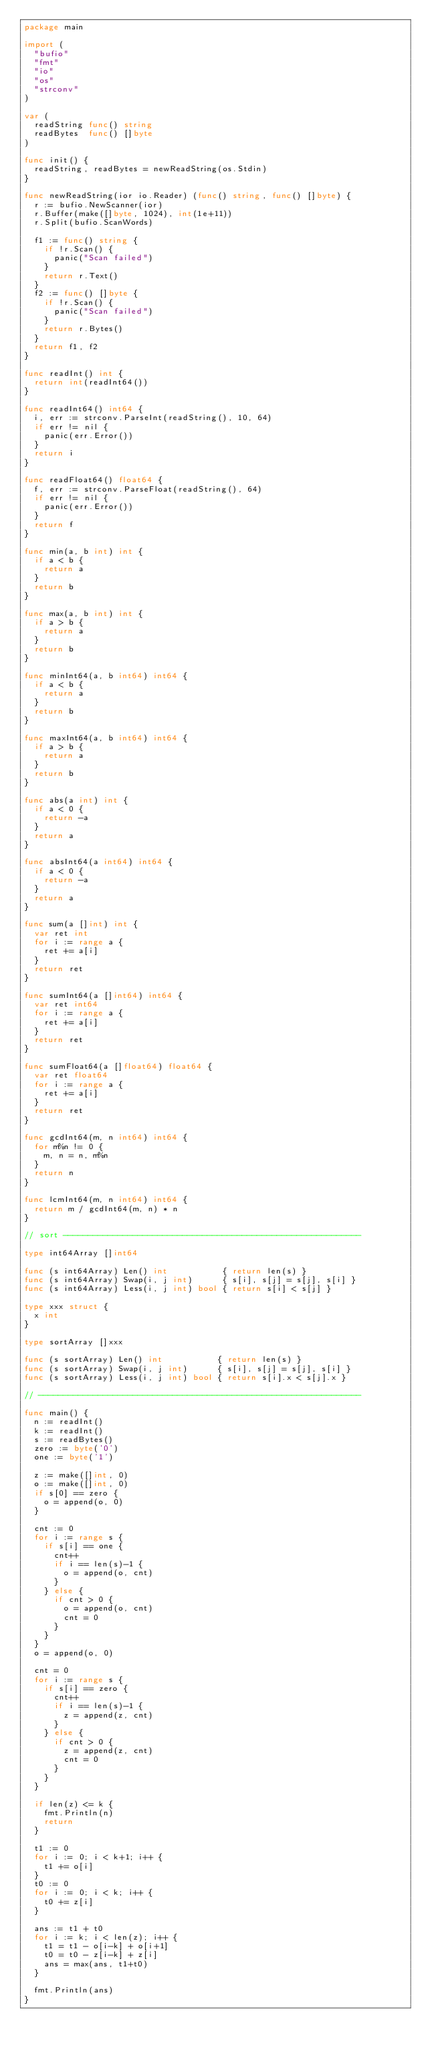Convert code to text. <code><loc_0><loc_0><loc_500><loc_500><_Go_>package main

import (
	"bufio"
	"fmt"
	"io"
	"os"
	"strconv"
)

var (
	readString func() string
	readBytes  func() []byte
)

func init() {
	readString, readBytes = newReadString(os.Stdin)
}

func newReadString(ior io.Reader) (func() string, func() []byte) {
	r := bufio.NewScanner(ior)
	r.Buffer(make([]byte, 1024), int(1e+11))
	r.Split(bufio.ScanWords)

	f1 := func() string {
		if !r.Scan() {
			panic("Scan failed")
		}
		return r.Text()
	}
	f2 := func() []byte {
		if !r.Scan() {
			panic("Scan failed")
		}
		return r.Bytes()
	}
	return f1, f2
}

func readInt() int {
	return int(readInt64())
}

func readInt64() int64 {
	i, err := strconv.ParseInt(readString(), 10, 64)
	if err != nil {
		panic(err.Error())
	}
	return i
}

func readFloat64() float64 {
	f, err := strconv.ParseFloat(readString(), 64)
	if err != nil {
		panic(err.Error())
	}
	return f
}

func min(a, b int) int {
	if a < b {
		return a
	}
	return b
}

func max(a, b int) int {
	if a > b {
		return a
	}
	return b
}

func minInt64(a, b int64) int64 {
	if a < b {
		return a
	}
	return b
}

func maxInt64(a, b int64) int64 {
	if a > b {
		return a
	}
	return b
}

func abs(a int) int {
	if a < 0 {
		return -a
	}
	return a
}

func absInt64(a int64) int64 {
	if a < 0 {
		return -a
	}
	return a
}

func sum(a []int) int {
	var ret int
	for i := range a {
		ret += a[i]
	}
	return ret
}

func sumInt64(a []int64) int64 {
	var ret int64
	for i := range a {
		ret += a[i]
	}
	return ret
}

func sumFloat64(a []float64) float64 {
	var ret float64
	for i := range a {
		ret += a[i]
	}
	return ret
}

func gcdInt64(m, n int64) int64 {
	for m%n != 0 {
		m, n = n, m%n
	}
	return n
}

func lcmInt64(m, n int64) int64 {
	return m / gcdInt64(m, n) * n
}

// sort ------------------------------------------------------------

type int64Array []int64

func (s int64Array) Len() int           { return len(s) }
func (s int64Array) Swap(i, j int)      { s[i], s[j] = s[j], s[i] }
func (s int64Array) Less(i, j int) bool { return s[i] < s[j] }

type xxx struct {
	x int
}

type sortArray []xxx

func (s sortArray) Len() int           { return len(s) }
func (s sortArray) Swap(i, j int)      { s[i], s[j] = s[j], s[i] }
func (s sortArray) Less(i, j int) bool { return s[i].x < s[j].x }

// -----------------------------------------------------------------

func main() {
	n := readInt()
	k := readInt()
	s := readBytes()
	zero := byte('0')
	one := byte('1')

	z := make([]int, 0)
	o := make([]int, 0)
	if s[0] == zero {
		o = append(o, 0)
	}

	cnt := 0
	for i := range s {
		if s[i] == one {
			cnt++
			if i == len(s)-1 {
				o = append(o, cnt)
			}
		} else {
			if cnt > 0 {
				o = append(o, cnt)
				cnt = 0
			}
		}
	}
	o = append(o, 0)

	cnt = 0
	for i := range s {
		if s[i] == zero {
			cnt++
			if i == len(s)-1 {
				z = append(z, cnt)
			}
		} else {
			if cnt > 0 {
				z = append(z, cnt)
				cnt = 0
			}
		}
	}

	if len(z) <= k {
		fmt.Println(n)
		return
	}

	t1 := 0
	for i := 0; i < k+1; i++ {
		t1 += o[i]
	}
	t0 := 0
	for i := 0; i < k; i++ {
		t0 += z[i]
	}

	ans := t1 + t0
	for i := k; i < len(z); i++ {
		t1 = t1 - o[i-k] + o[i+1]
		t0 = t0 - z[i-k] + z[i]
		ans = max(ans, t1+t0)
	}

	fmt.Println(ans)
}
</code> 